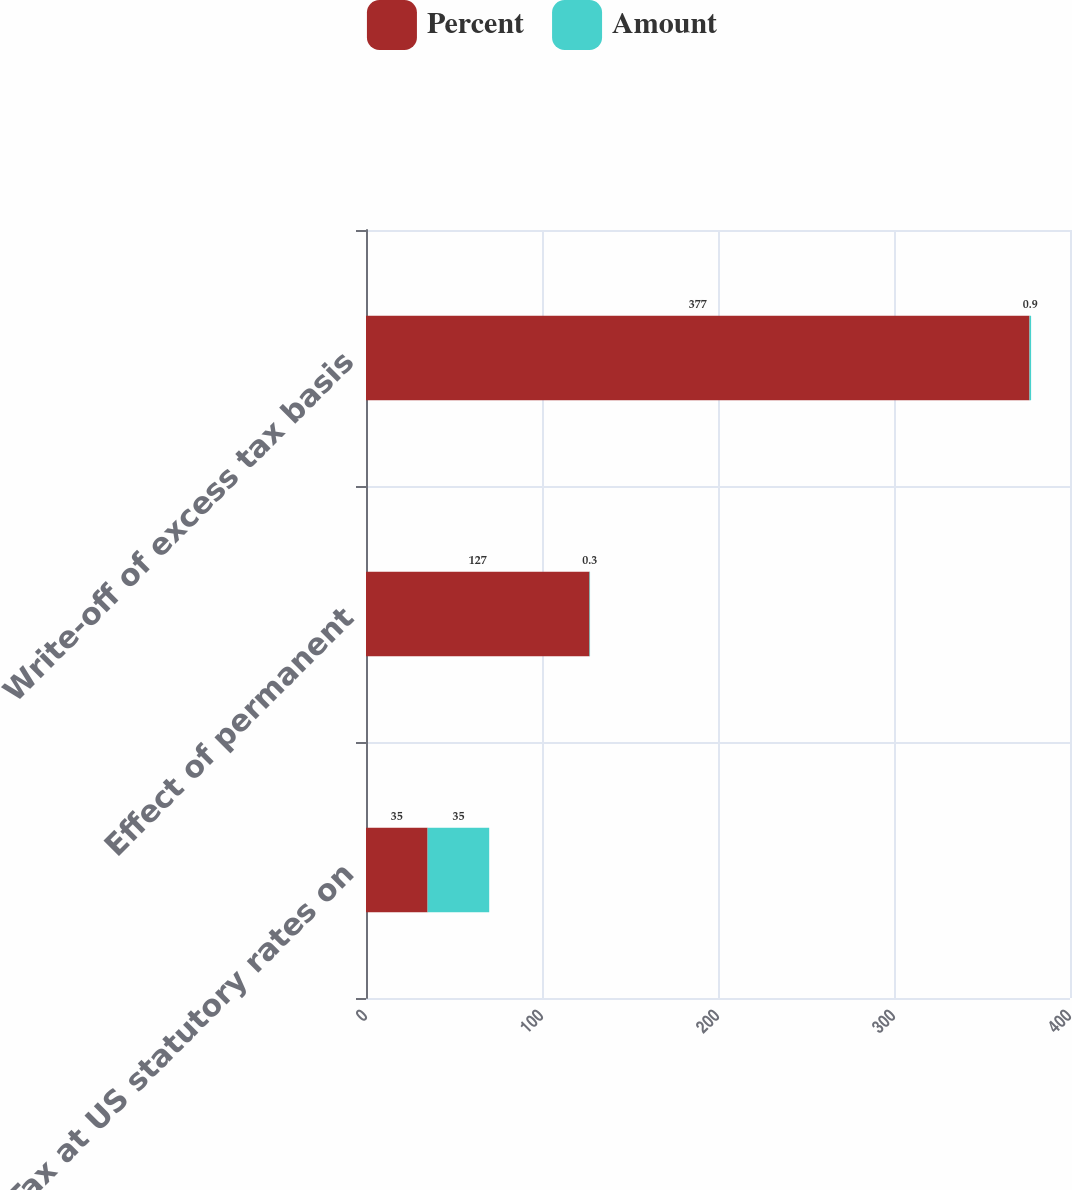Convert chart. <chart><loc_0><loc_0><loc_500><loc_500><stacked_bar_chart><ecel><fcel>Tax at US statutory rates on<fcel>Effect of permanent<fcel>Write-off of excess tax basis<nl><fcel>Percent<fcel>35<fcel>127<fcel>377<nl><fcel>Amount<fcel>35<fcel>0.3<fcel>0.9<nl></chart> 